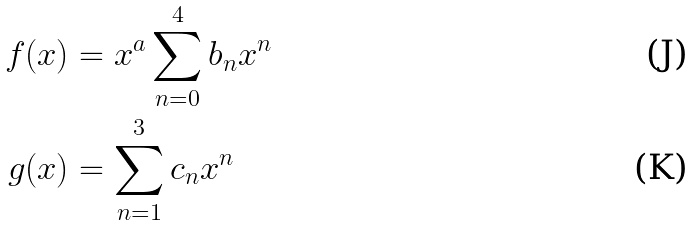<formula> <loc_0><loc_0><loc_500><loc_500>f ( x ) & = x ^ { a } \sum _ { n = 0 } ^ { 4 } b _ { n } x ^ { n } \\ g ( x ) & = \sum _ { n = 1 } ^ { 3 } c _ { n } x ^ { n }</formula> 